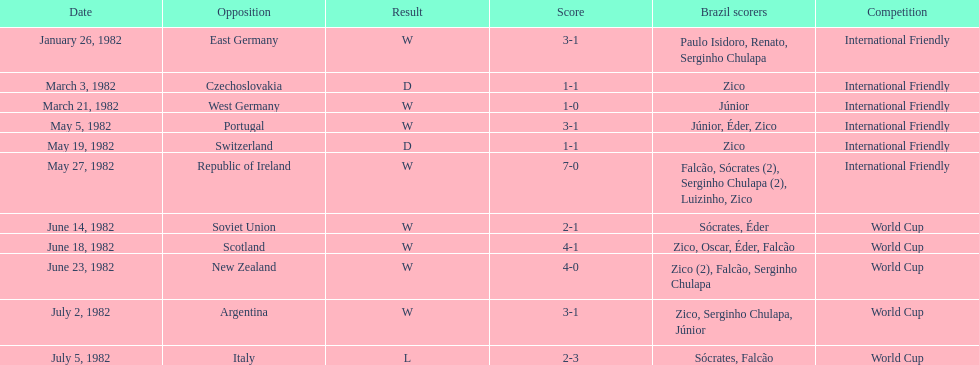During the 1982 season, how many encounters took place between brazil and west germany? 1. 